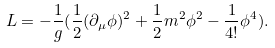Convert formula to latex. <formula><loc_0><loc_0><loc_500><loc_500>L = - \frac { 1 } { g } ( \frac { 1 } { 2 } ( \partial _ { \mu } \phi ) ^ { 2 } + \frac { 1 } { 2 } m ^ { 2 } \phi ^ { 2 } - \frac { 1 } { 4 ! } \phi ^ { 4 } ) .</formula> 